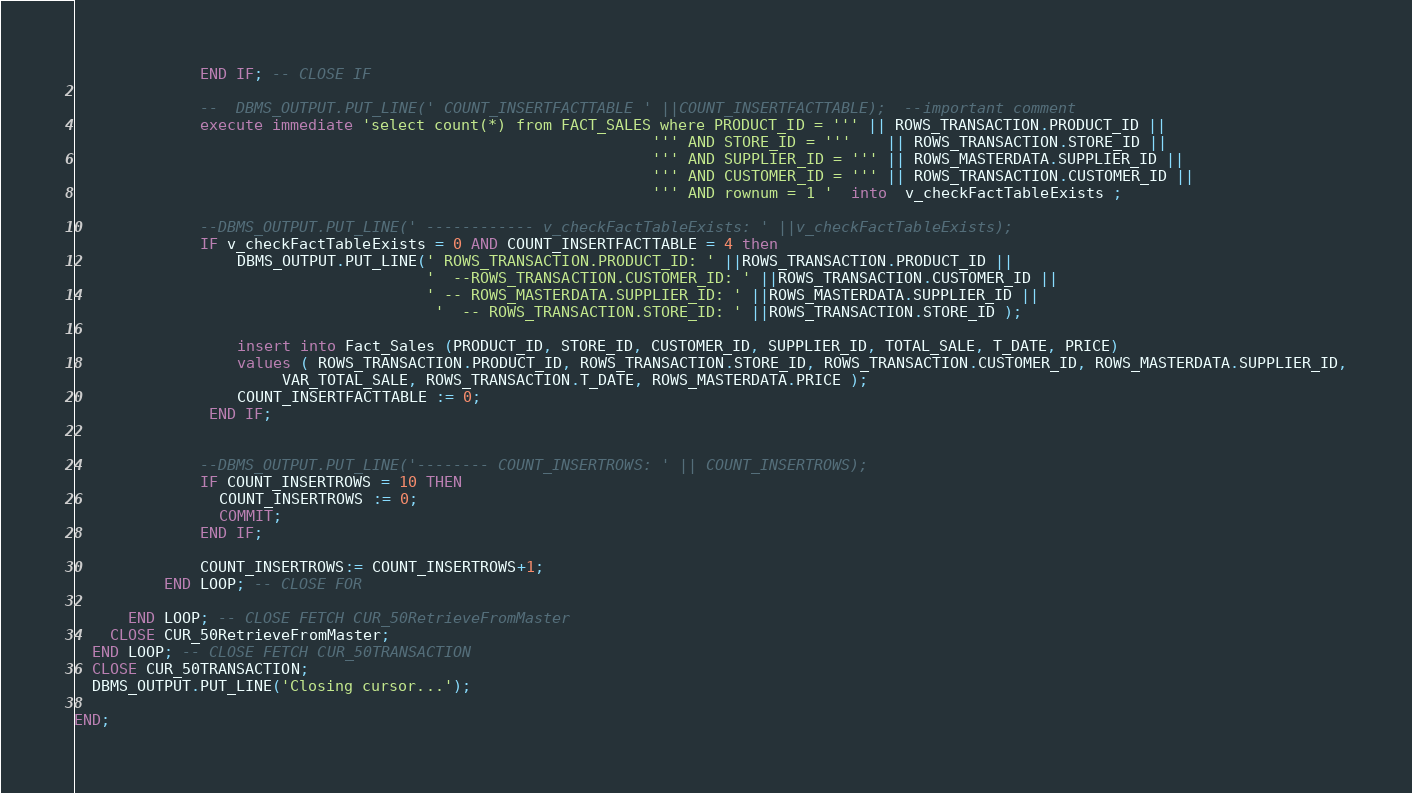Convert code to text. <code><loc_0><loc_0><loc_500><loc_500><_SQL_>              END IF; -- CLOSE IF 
             
              --  DBMS_OUTPUT.PUT_LINE(' COUNT_INSERTFACTTABLE ' ||COUNT_INSERTFACTTABLE);  --important comment
              execute immediate 'select count(*) from FACT_SALES where PRODUCT_ID = ''' || ROWS_TRANSACTION.PRODUCT_ID || 
                                                                ''' AND STORE_ID = '''    || ROWS_TRANSACTION.STORE_ID ||
                                                                ''' AND SUPPLIER_ID = ''' || ROWS_MASTERDATA.SUPPLIER_ID ||
                                                                ''' AND CUSTOMER_ID = ''' || ROWS_TRANSACTION.CUSTOMER_ID ||
                                                                ''' AND rownum = 1 '  into  v_checkFactTableExists ;
                                                                 
              --DBMS_OUTPUT.PUT_LINE(' ------------ v_checkFactTableExists: ' ||v_checkFactTableExists);
              IF v_checkFactTableExists = 0 AND COUNT_INSERTFACTTABLE = 4 then 
                  DBMS_OUTPUT.PUT_LINE(' ROWS_TRANSACTION.PRODUCT_ID: ' ||ROWS_TRANSACTION.PRODUCT_ID ||
                                       '  --ROWS_TRANSACTION.CUSTOMER_ID: ' ||ROWS_TRANSACTION.CUSTOMER_ID || 
                                       ' -- ROWS_MASTERDATA.SUPPLIER_ID: ' ||ROWS_MASTERDATA.SUPPLIER_ID ||
                                        '  -- ROWS_TRANSACTION.STORE_ID: ' ||ROWS_TRANSACTION.STORE_ID );
                    
                  insert into Fact_Sales (PRODUCT_ID, STORE_ID, CUSTOMER_ID, SUPPLIER_ID, TOTAL_SALE, T_DATE, PRICE)
                  values ( ROWS_TRANSACTION.PRODUCT_ID, ROWS_TRANSACTION.STORE_ID, ROWS_TRANSACTION.CUSTOMER_ID, ROWS_MASTERDATA.SUPPLIER_ID,
                       VAR_TOTAL_SALE, ROWS_TRANSACTION.T_DATE, ROWS_MASTERDATA.PRICE );
                  COUNT_INSERTFACTTABLE := 0;
               END IF;
             
             
              --DBMS_OUTPUT.PUT_LINE('-------- COUNT_INSERTROWS: ' || COUNT_INSERTROWS);				
              IF COUNT_INSERTROWS = 10 THEN
                COUNT_INSERTROWS := 0;
                COMMIT;
              END IF;        
             
              COUNT_INSERTROWS:= COUNT_INSERTROWS+1;
          END LOOP; -- CLOSE FOR
											
      END LOOP; -- CLOSE FETCH CUR_50RetrieveFromMaster
	CLOSE CUR_50RetrieveFromMaster;
  END LOOP; -- CLOSE FETCH CUR_50TRANSACTION
  CLOSE CUR_50TRANSACTION;
  DBMS_OUTPUT.PUT_LINE('Closing cursor...');
 
END;
</code> 